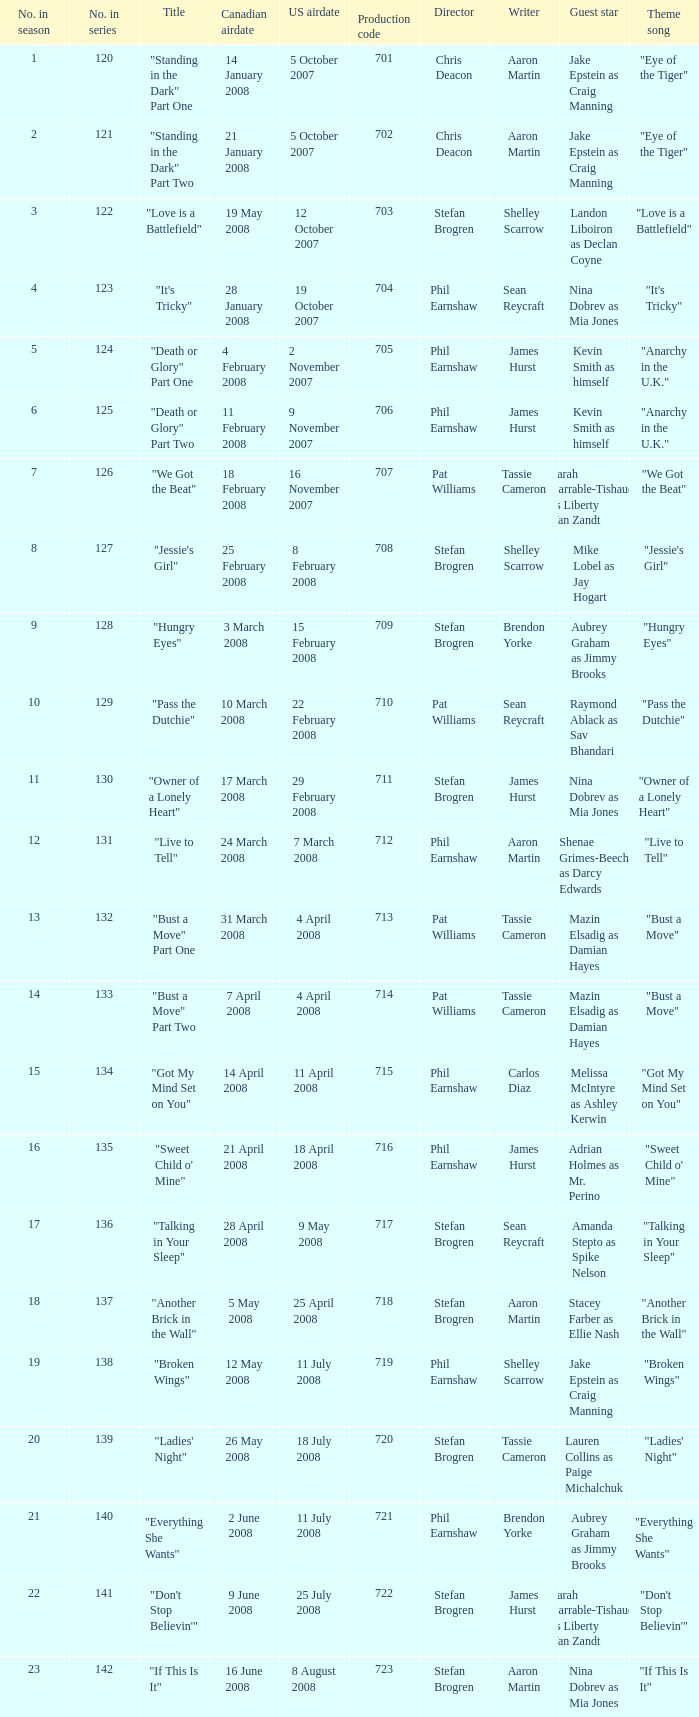The U.S. airdate of 8 august 2008 also had canadian airdates of what? 16 June 2008. 